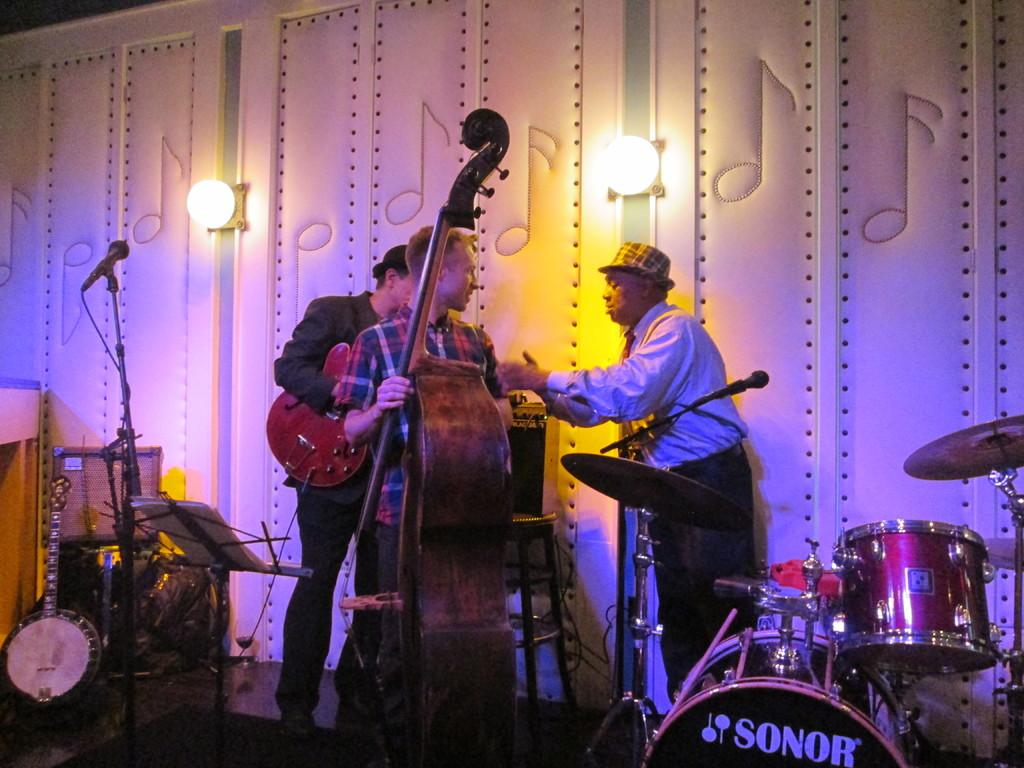How many men are present in the image? There are three men in the image. What are two of the men doing in the image? Two of the men are holding musical instruments. Are there any other objects related to music in the image? Yes, there are other musical instruments in the image. What can be seen in the background of the image? There are two lights in the background of the image. What type of bomb is being diffused by the men in the image? There is no bomb present in the image; the men are holding musical instruments. What month is it in the image? The image does not provide any information about the month or time of year. 